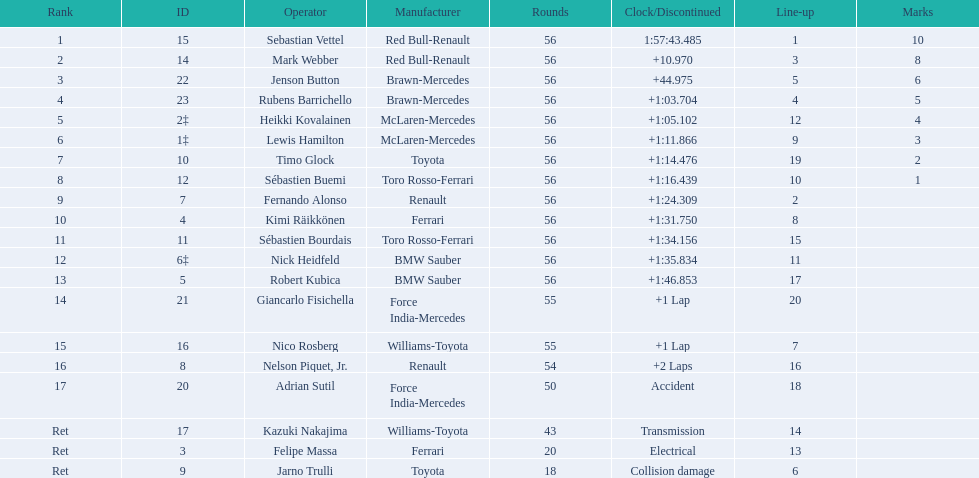Why did the  toyota retire Collision damage. What was the drivers name? Jarno Trulli. 